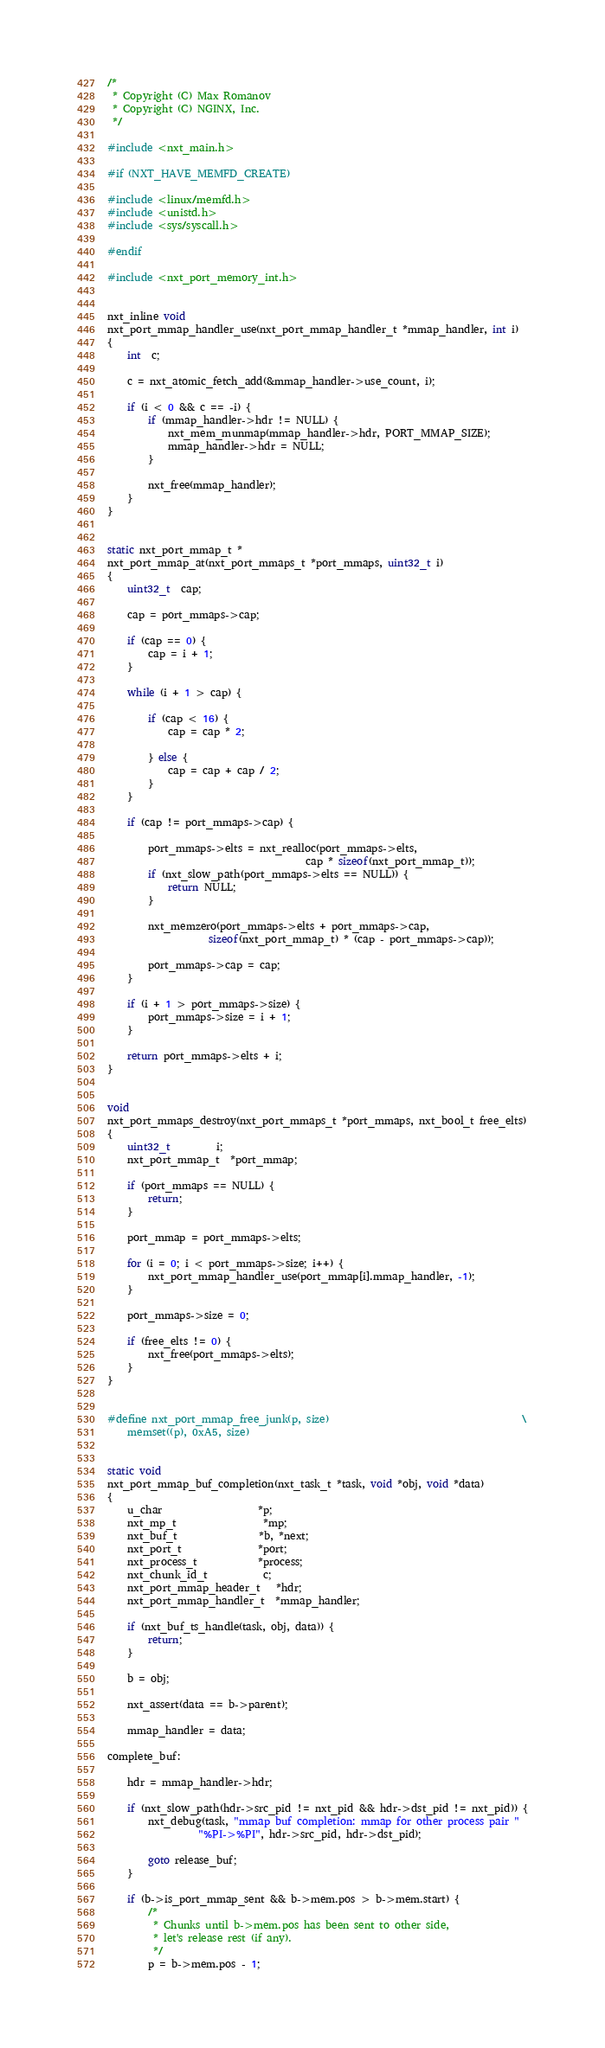<code> <loc_0><loc_0><loc_500><loc_500><_C_>
/*
 * Copyright (C) Max Romanov
 * Copyright (C) NGINX, Inc.
 */

#include <nxt_main.h>

#if (NXT_HAVE_MEMFD_CREATE)

#include <linux/memfd.h>
#include <unistd.h>
#include <sys/syscall.h>

#endif

#include <nxt_port_memory_int.h>


nxt_inline void
nxt_port_mmap_handler_use(nxt_port_mmap_handler_t *mmap_handler, int i)
{
    int  c;

    c = nxt_atomic_fetch_add(&mmap_handler->use_count, i);

    if (i < 0 && c == -i) {
        if (mmap_handler->hdr != NULL) {
            nxt_mem_munmap(mmap_handler->hdr, PORT_MMAP_SIZE);
            mmap_handler->hdr = NULL;
        }

        nxt_free(mmap_handler);
    }
}


static nxt_port_mmap_t *
nxt_port_mmap_at(nxt_port_mmaps_t *port_mmaps, uint32_t i)
{
    uint32_t  cap;

    cap = port_mmaps->cap;

    if (cap == 0) {
        cap = i + 1;
    }

    while (i + 1 > cap) {

        if (cap < 16) {
            cap = cap * 2;

        } else {
            cap = cap + cap / 2;
        }
    }

    if (cap != port_mmaps->cap) {

        port_mmaps->elts = nxt_realloc(port_mmaps->elts,
                                       cap * sizeof(nxt_port_mmap_t));
        if (nxt_slow_path(port_mmaps->elts == NULL)) {
            return NULL;
        }

        nxt_memzero(port_mmaps->elts + port_mmaps->cap,
                    sizeof(nxt_port_mmap_t) * (cap - port_mmaps->cap));

        port_mmaps->cap = cap;
    }

    if (i + 1 > port_mmaps->size) {
        port_mmaps->size = i + 1;
    }

    return port_mmaps->elts + i;
}


void
nxt_port_mmaps_destroy(nxt_port_mmaps_t *port_mmaps, nxt_bool_t free_elts)
{
    uint32_t         i;
    nxt_port_mmap_t  *port_mmap;

    if (port_mmaps == NULL) {
        return;
    }

    port_mmap = port_mmaps->elts;

    for (i = 0; i < port_mmaps->size; i++) {
        nxt_port_mmap_handler_use(port_mmap[i].mmap_handler, -1);
    }

    port_mmaps->size = 0;

    if (free_elts != 0) {
        nxt_free(port_mmaps->elts);
    }
}


#define nxt_port_mmap_free_junk(p, size)                                      \
    memset((p), 0xA5, size)


static void
nxt_port_mmap_buf_completion(nxt_task_t *task, void *obj, void *data)
{
    u_char                   *p;
    nxt_mp_t                 *mp;
    nxt_buf_t                *b, *next;
    nxt_port_t               *port;
    nxt_process_t            *process;
    nxt_chunk_id_t           c;
    nxt_port_mmap_header_t   *hdr;
    nxt_port_mmap_handler_t  *mmap_handler;

    if (nxt_buf_ts_handle(task, obj, data)) {
        return;
    }

    b = obj;

    nxt_assert(data == b->parent);

    mmap_handler = data;

complete_buf:

    hdr = mmap_handler->hdr;

    if (nxt_slow_path(hdr->src_pid != nxt_pid && hdr->dst_pid != nxt_pid)) {
        nxt_debug(task, "mmap buf completion: mmap for other process pair "
                  "%PI->%PI", hdr->src_pid, hdr->dst_pid);

        goto release_buf;
    }

    if (b->is_port_mmap_sent && b->mem.pos > b->mem.start) {
        /*
         * Chunks until b->mem.pos has been sent to other side,
         * let's release rest (if any).
         */
        p = b->mem.pos - 1;</code> 